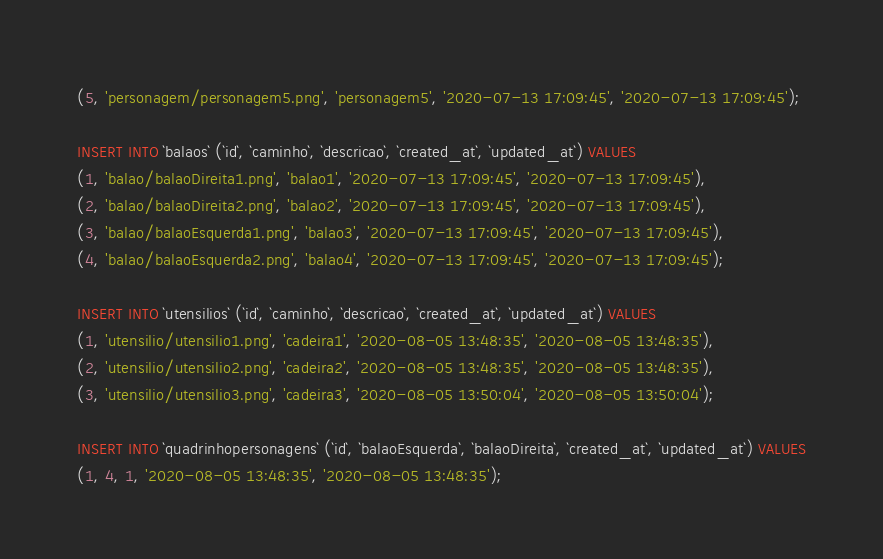<code> <loc_0><loc_0><loc_500><loc_500><_SQL_>(5, 'personagem/personagem5.png', 'personagem5', '2020-07-13 17:09:45', '2020-07-13 17:09:45');

INSERT INTO `balaos` (`id`, `caminho`, `descricao`, `created_at`, `updated_at`) VALUES
(1, 'balao/balaoDireita1.png', 'balao1', '2020-07-13 17:09:45', '2020-07-13 17:09:45'),
(2, 'balao/balaoDireita2.png', 'balao2', '2020-07-13 17:09:45', '2020-07-13 17:09:45'),
(3, 'balao/balaoEsquerda1.png', 'balao3', '2020-07-13 17:09:45', '2020-07-13 17:09:45'),
(4, 'balao/balaoEsquerda2.png', 'balao4', '2020-07-13 17:09:45', '2020-07-13 17:09:45');

INSERT INTO `utensilios` (`id`, `caminho`, `descricao`, `created_at`, `updated_at`) VALUES
(1, 'utensilio/utensilio1.png', 'cadeira1', '2020-08-05 13:48:35', '2020-08-05 13:48:35'),
(2, 'utensilio/utensilio2.png', 'cadeira2', '2020-08-05 13:48:35', '2020-08-05 13:48:35'),
(3, 'utensilio/utensilio3.png', 'cadeira3', '2020-08-05 13:50:04', '2020-08-05 13:50:04');

INSERT INTO `quadrinhopersonagens` (`id`, `balaoEsquerda`, `balaoDireita`, `created_at`, `updated_at`) VALUES
(1, 4, 1, '2020-08-05 13:48:35', '2020-08-05 13:48:35');</code> 